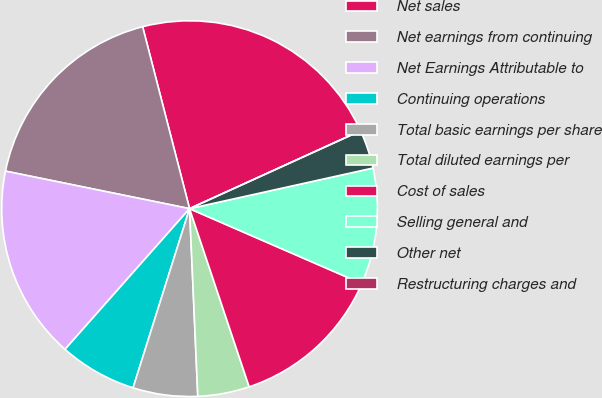Convert chart. <chart><loc_0><loc_0><loc_500><loc_500><pie_chart><fcel>Net sales<fcel>Net earnings from continuing<fcel>Net Earnings Attributable to<fcel>Continuing operations<fcel>Total basic earnings per share<fcel>Total diluted earnings per<fcel>Cost of sales<fcel>Selling general and<fcel>Other net<fcel>Restructuring charges and<nl><fcel>22.22%<fcel>17.78%<fcel>16.67%<fcel>6.67%<fcel>5.56%<fcel>4.44%<fcel>13.33%<fcel>10.0%<fcel>3.33%<fcel>0.0%<nl></chart> 